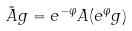Convert formula to latex. <formula><loc_0><loc_0><loc_500><loc_500>\tilde { A } g = e ^ { - \varphi } A ( e ^ { \varphi } g )</formula> 